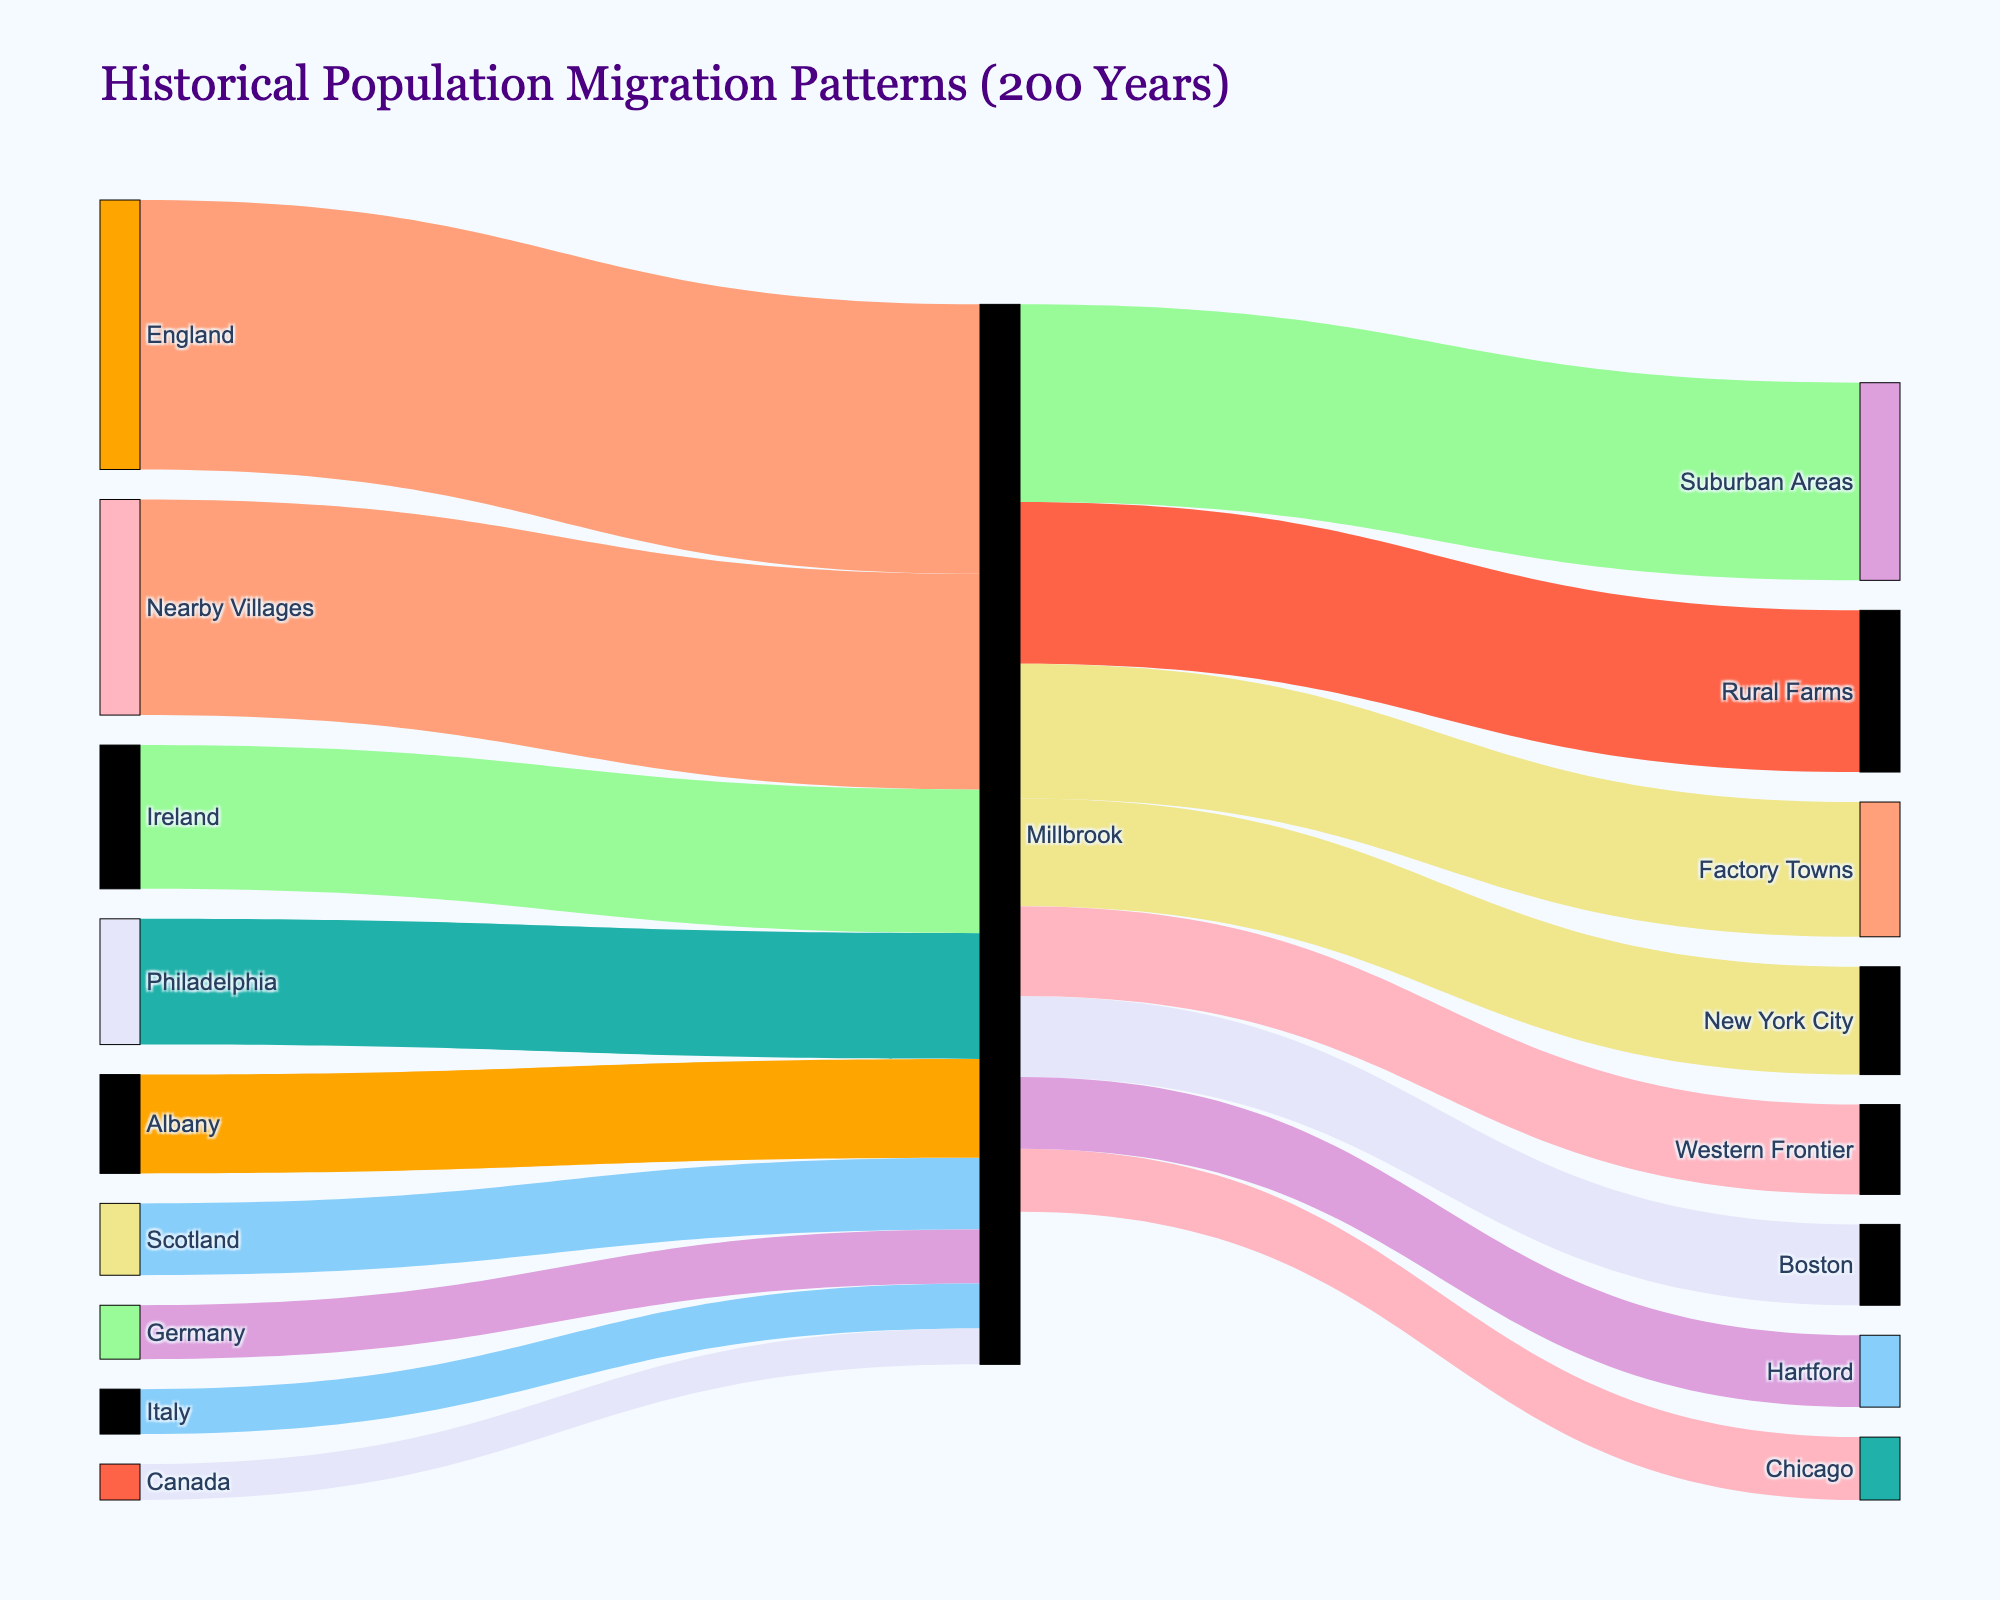How many origins are shown migrating to Millbrook? Counting all unique source locations linked to Millbrook in the figure, we get England, Ireland, Scotland, Germany, Philadelphia, Albany, Nearby Villages, Italy, Canada, and Boston. Thus, there are 10 origins in total.
Answer: 10 Which destination has the highest migration from Millbrook? By visually inspecting the diagram, the destination with the thickest link from Millbrook is the Suburban Areas with a value of 110.
Answer: Suburban Areas What is the total number of people migrating out of Millbrook? Adding up all the migration values from Millbrook to various destinations, we have: 60 (New York City) + 45 (Boston) + 35 (Chicago) + 90 (Rural Farms) + 110 (Suburban Areas) + 40 (Hartford) + 75 (Factory Towns) + 50 (Western Frontier) = 505.
Answer: 505 Which source has the smallest migration value to Millbrook? Checking all the source nodes linked to Millbrook, the smallest migration value comes from Canada with a value of 20.
Answer: Canada What is the combined migration value from the nearby areas (Philadelphia, Albany, Nearby Villages) to Millbrook? Adding the migration values from Philadelphia, Albany, and Nearby Villages to Millbrook, we get: 70 (Philadelphia) + 55 (Albany) + 120 (Nearby Villages) = 245.
Answer: 245 Which had more migration to Millbrook: Germany or Italy? Checking the values, Germany has a migration value of 30, while Italy has a value of 25. Germany has more migration to Millbrook.
Answer: Germany Can you compare the migration from England to Millbrook with the migration from Millbrook to Suburban Areas? The migration from England to Millbrook is 150, while the migration from Millbrook to Suburban Areas is 110. Thus, the migration from England to Millbrook is greater.
Answer: England to Millbrook How does the migration from Rural Farms to Millbrook compare with the migration from Millbrook to Rural Farms? The migration from Rural Farms to Millbrook is not listed; however, the migration from Millbrook to Rural Farms is 90. Therefore, we can say Millbrook has a migration link to Rural Farms but not the other way around.
Answer: Millbrook to Rural Farms only 